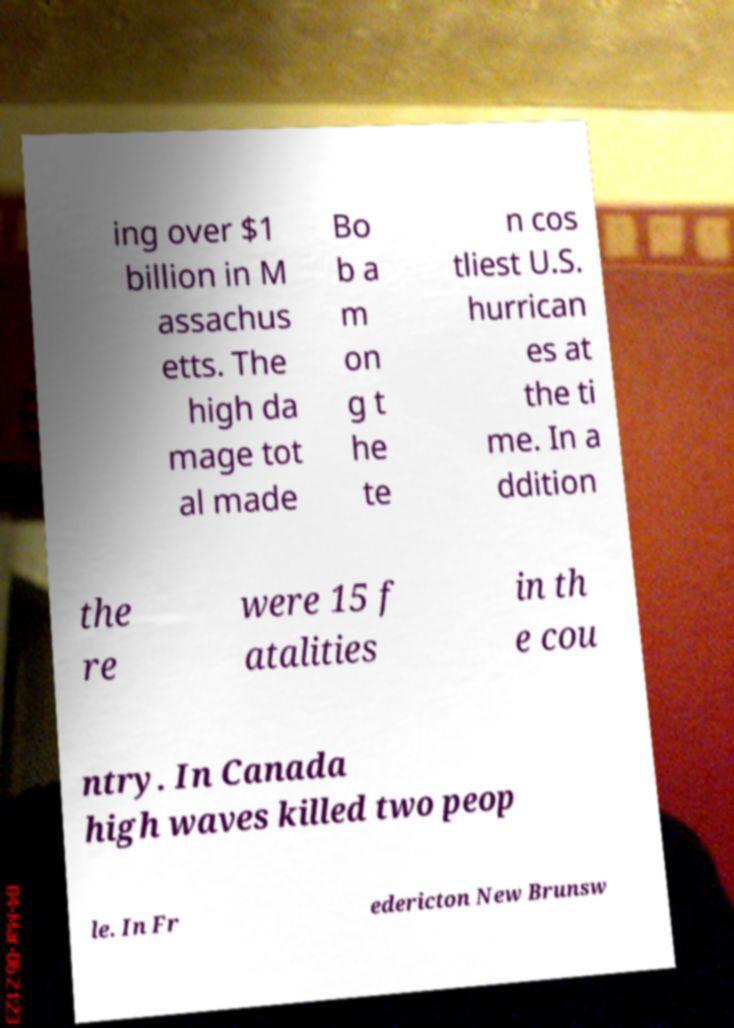Can you read and provide the text displayed in the image?This photo seems to have some interesting text. Can you extract and type it out for me? ing over $1 billion in M assachus etts. The high da mage tot al made Bo b a m on g t he te n cos tliest U.S. hurrican es at the ti me. In a ddition the re were 15 f atalities in th e cou ntry. In Canada high waves killed two peop le. In Fr edericton New Brunsw 